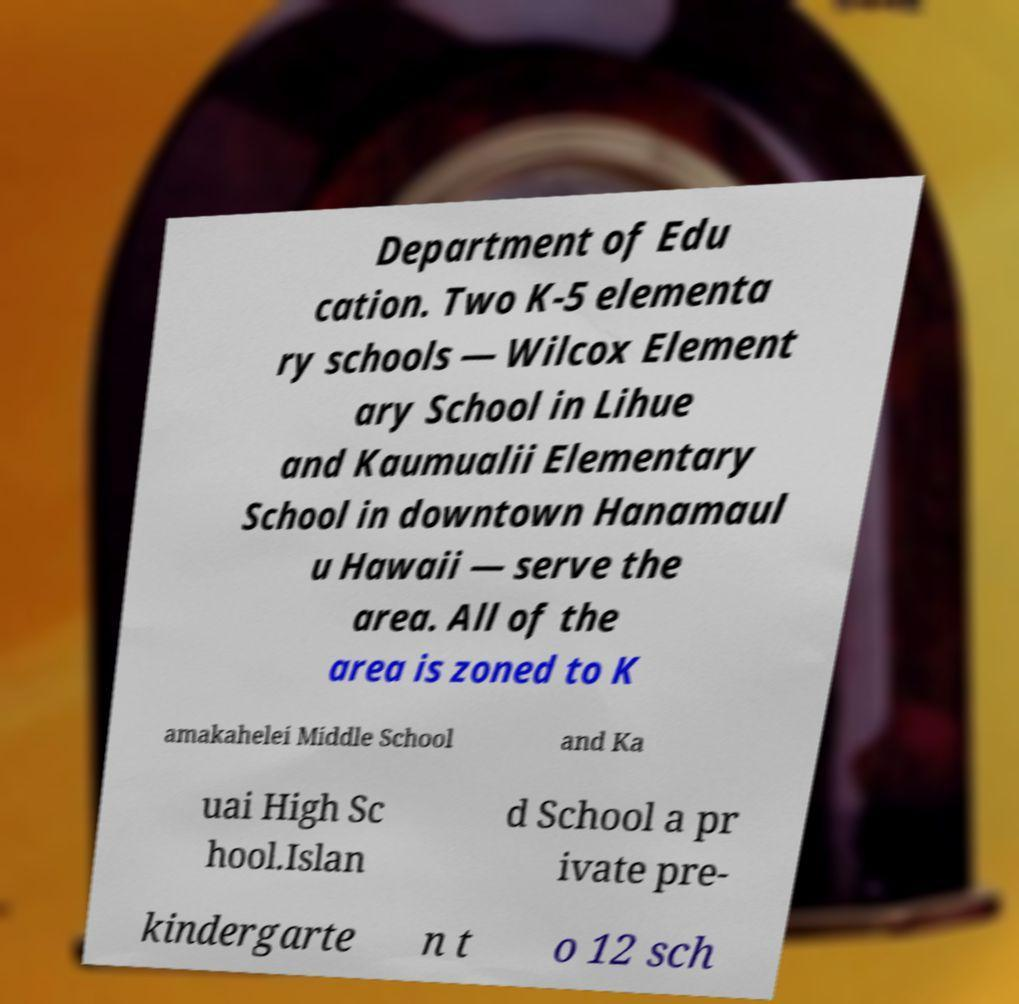For documentation purposes, I need the text within this image transcribed. Could you provide that? Department of Edu cation. Two K-5 elementa ry schools — Wilcox Element ary School in Lihue and Kaumualii Elementary School in downtown Hanamaul u Hawaii — serve the area. All of the area is zoned to K amakahelei Middle School and Ka uai High Sc hool.Islan d School a pr ivate pre- kindergarte n t o 12 sch 